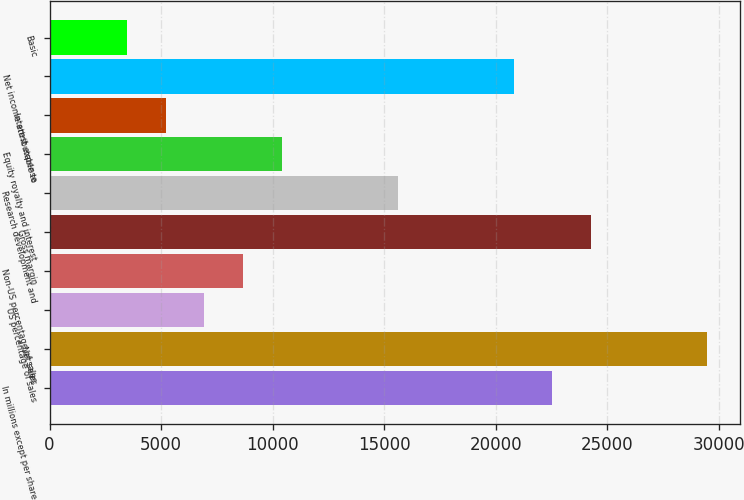Convert chart. <chart><loc_0><loc_0><loc_500><loc_500><bar_chart><fcel>In millions except per share<fcel>Net sales<fcel>US percentage of sales<fcel>Non-US percentage of sales<fcel>Gross margin<fcel>Research development and<fcel>Equity royalty and interest<fcel>Interest expense<fcel>Net income attributable to<fcel>Basic<nl><fcel>22533.7<fcel>29466.5<fcel>6934.68<fcel>8667.9<fcel>24266.9<fcel>15600.8<fcel>10401.1<fcel>5201.46<fcel>20800.4<fcel>3468.24<nl></chart> 